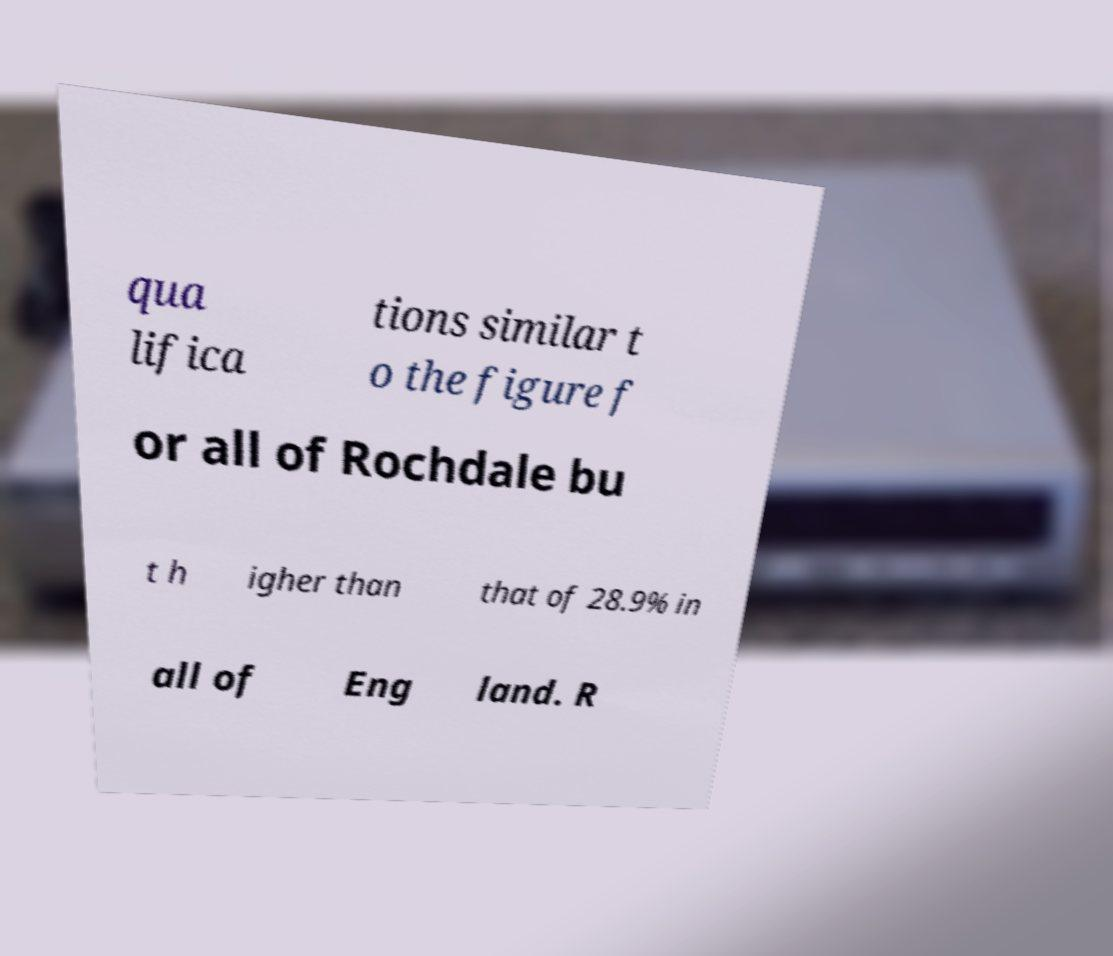What messages or text are displayed in this image? I need them in a readable, typed format. qua lifica tions similar t o the figure f or all of Rochdale bu t h igher than that of 28.9% in all of Eng land. R 